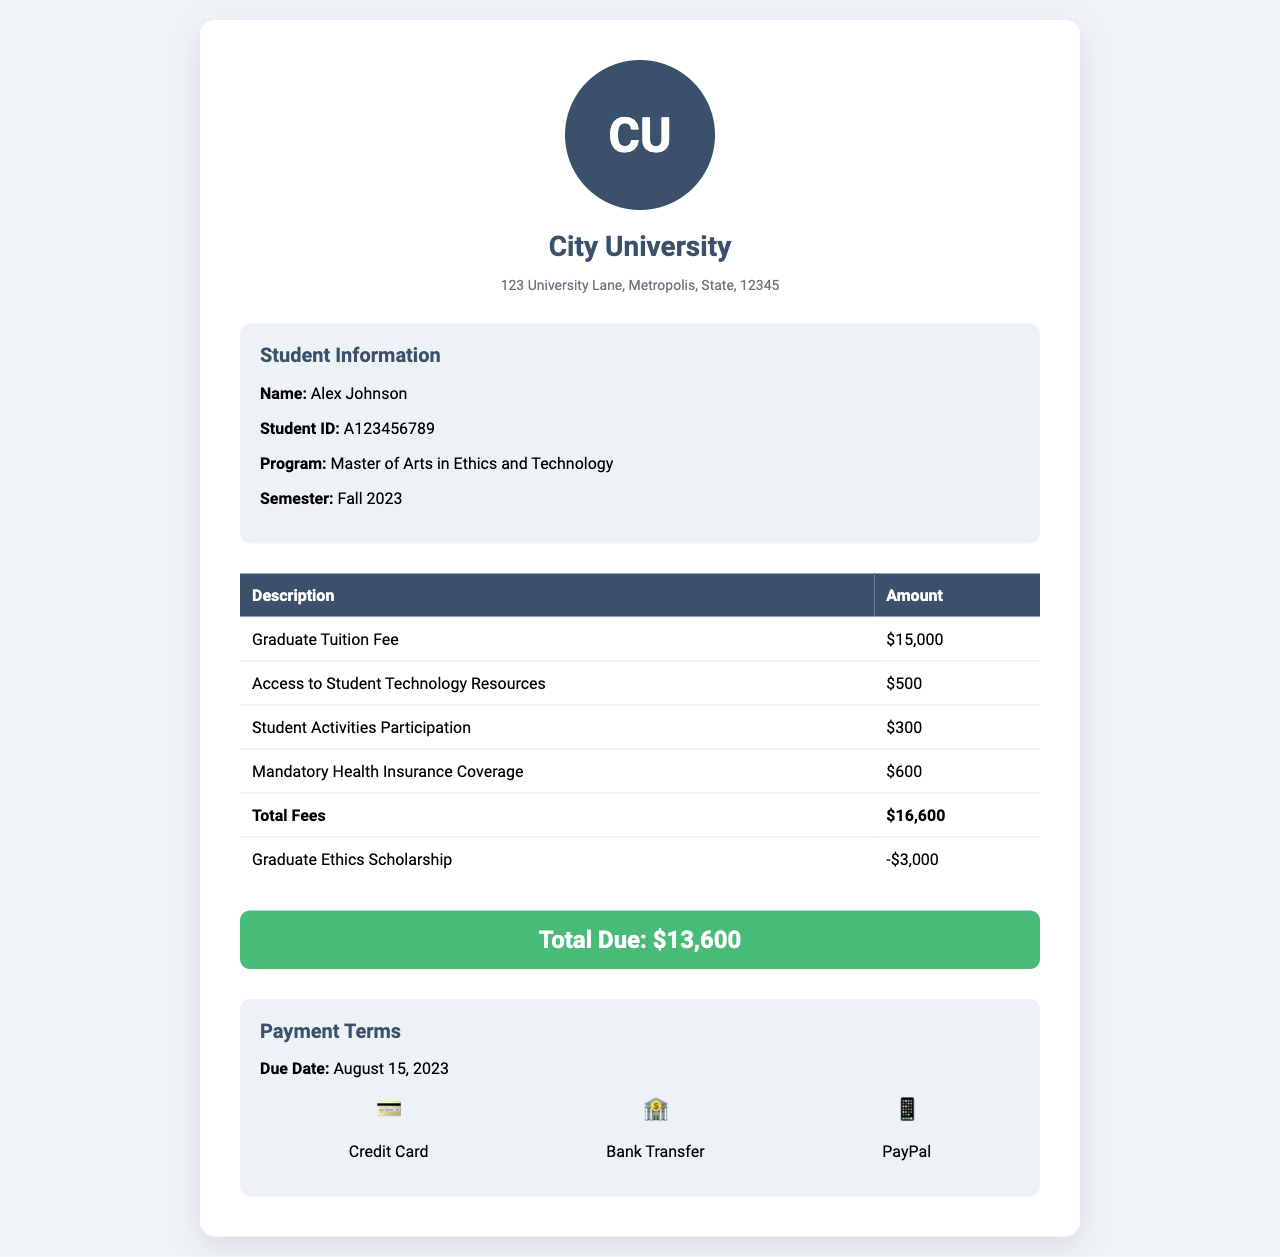What is the student's name? The student's name is listed in the student information section of the document.
Answer: Alex Johnson What is the Total Fees amount? The Total Fees amount is specified in the fee table section of the document.
Answer: $16,600 What scholarship is applied? The scholarship applied is mentioned in the fee table section.
Answer: Graduate Ethics Scholarship What is the total amount due? The total amount due is provided prominently in the invoice.
Answer: $13,600 What is the due date for payment? The due date for payment is stated in the payment terms section.
Answer: August 15, 2023 How much is the Graduate Tuition Fee? The Graduate Tuition Fee is listed in the fee table under 'Description.'
Answer: $15,000 What is included in the mandatory fees? Multiple fees are listed in the fee table, such as tuition fee and health insurance.
Answer: Graduate Tuition Fee, Access to Student Technology Resources, Student Activities Participation, Mandatory Health Insurance Coverage How many payment methods are offered? The number of payment methods is stated in the payment terms section.
Answer: Three 